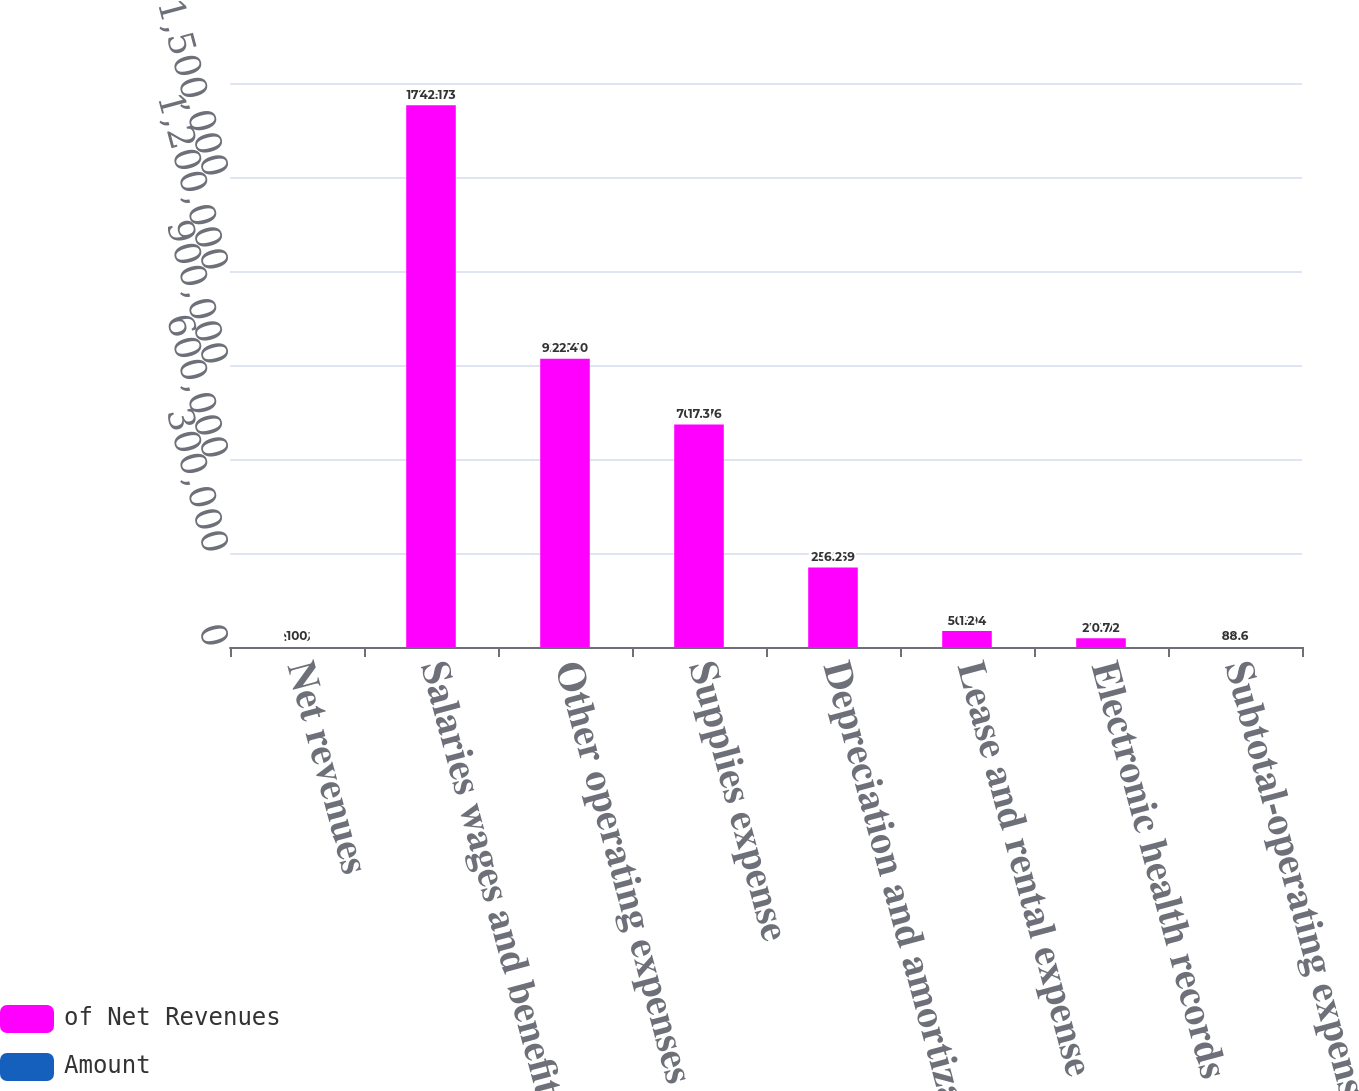<chart> <loc_0><loc_0><loc_500><loc_500><stacked_bar_chart><ecel><fcel>Net revenues<fcel>Salaries wages and benefits<fcel>Other operating expenses<fcel>Supplies expense<fcel>Depreciation and amortization<fcel>Lease and rental expense<fcel>Electronic health records<fcel>Subtotal-operating expenses<nl><fcel>of Net Revenues<fcel>94.3<fcel>1.72897e+06<fcel>920050<fcel>709776<fcel>253769<fcel>50794<fcel>27902<fcel>94.3<nl><fcel>Amount<fcel>100<fcel>42.1<fcel>22.4<fcel>17.3<fcel>6.2<fcel>1.2<fcel>0.7<fcel>88.6<nl></chart> 